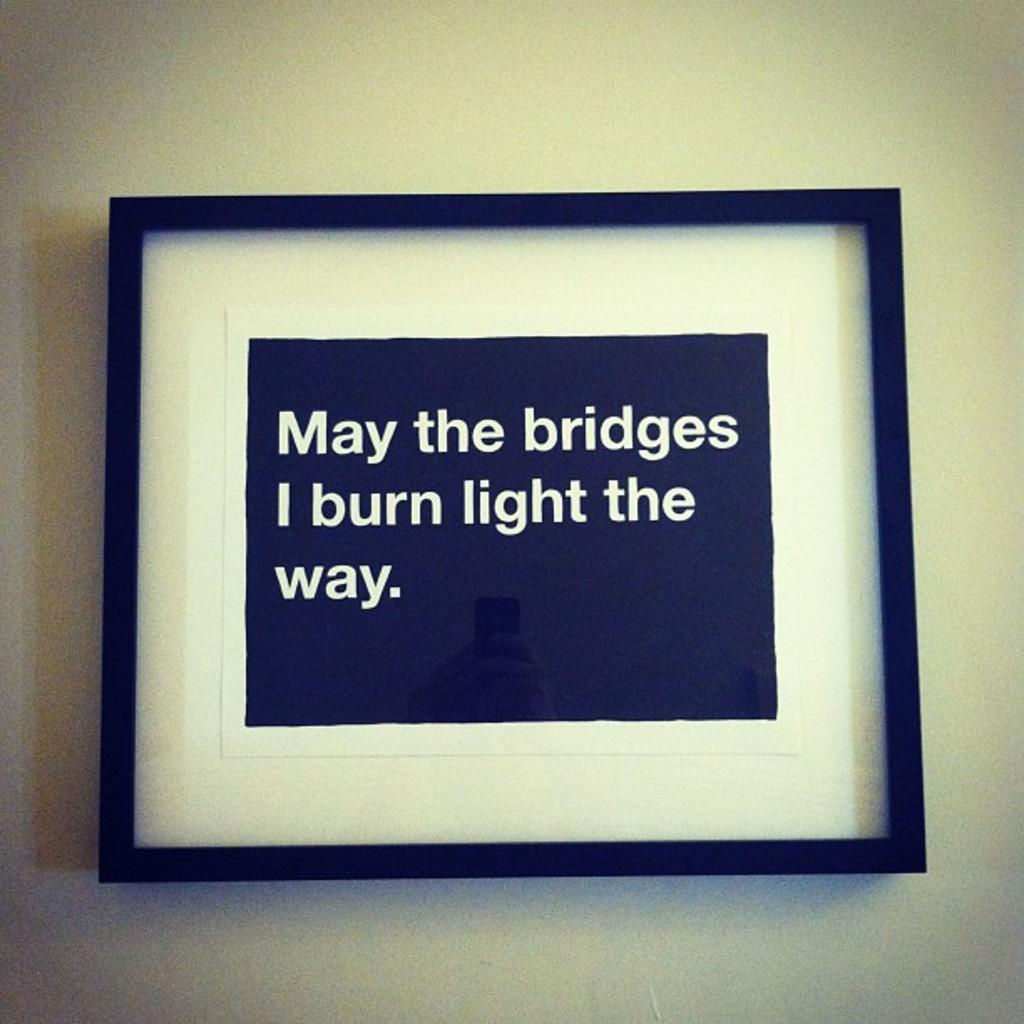<image>
Create a compact narrative representing the image presented. An inspirational quote in a black frame discusses burned bridges. 